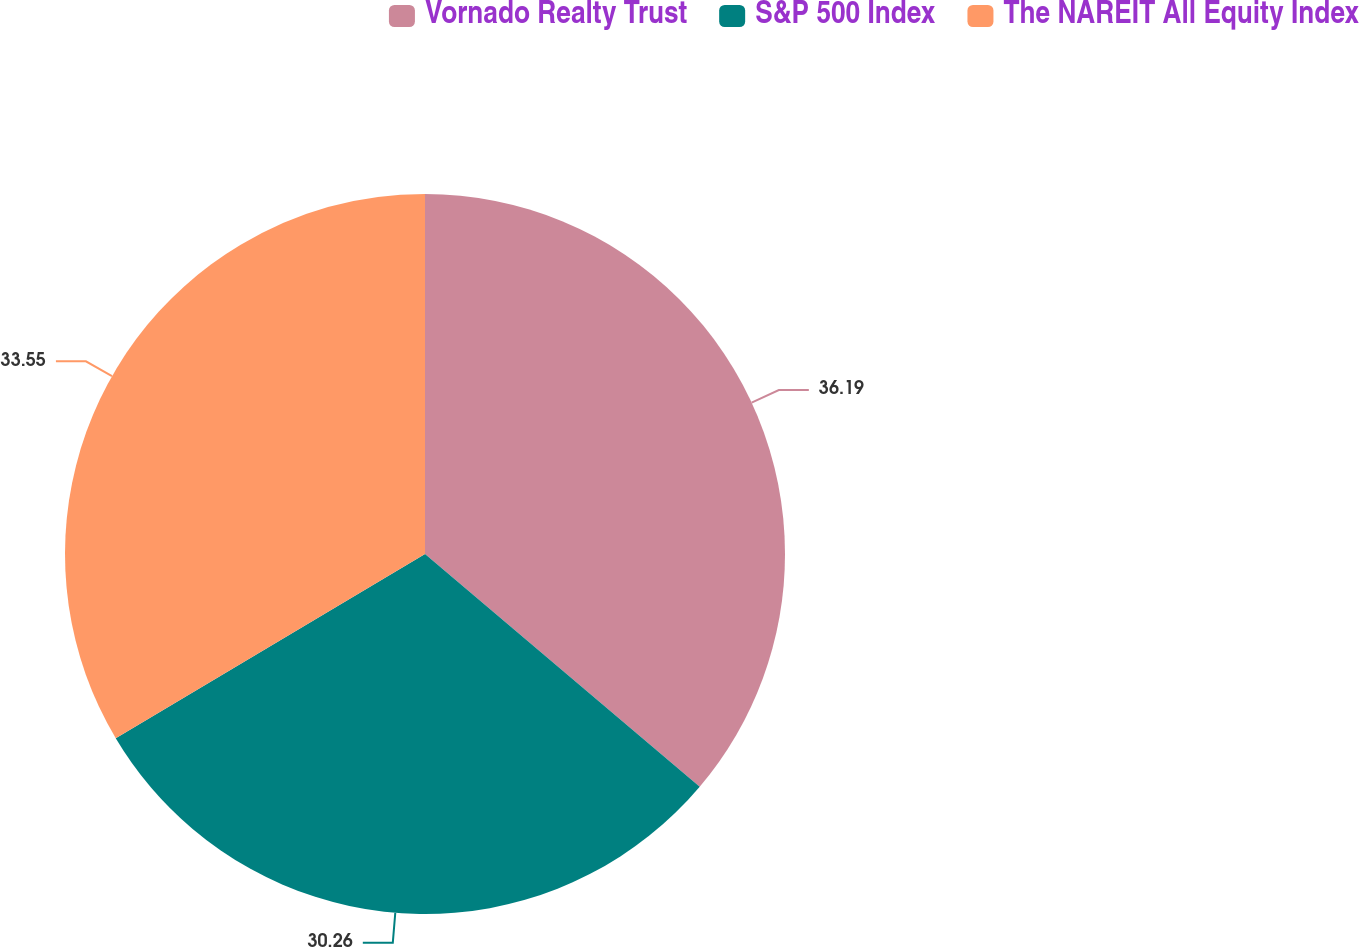Convert chart to OTSL. <chart><loc_0><loc_0><loc_500><loc_500><pie_chart><fcel>Vornado Realty Trust<fcel>S&P 500 Index<fcel>The NAREIT All Equity Index<nl><fcel>36.18%<fcel>30.26%<fcel>33.55%<nl></chart> 